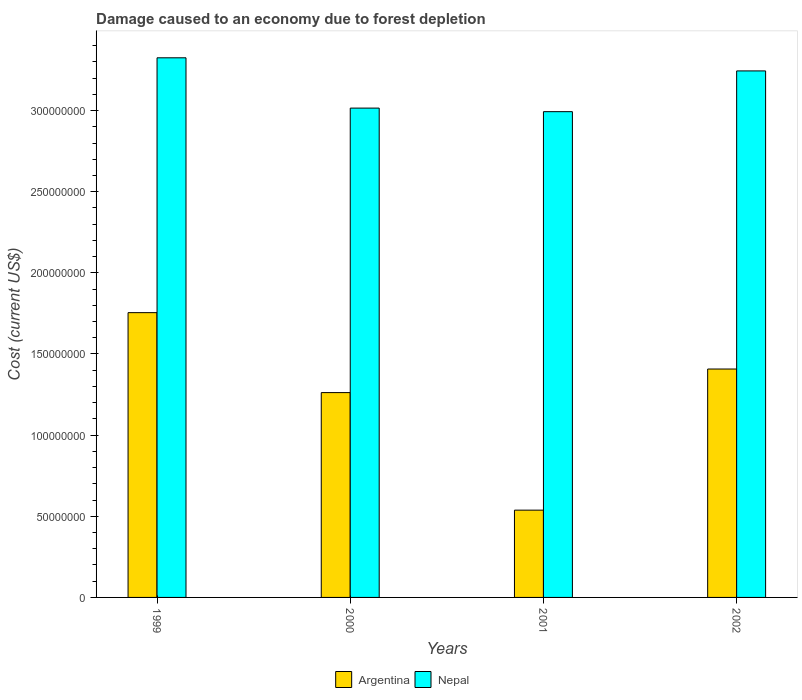Are the number of bars per tick equal to the number of legend labels?
Your answer should be very brief. Yes. How many bars are there on the 2nd tick from the left?
Offer a terse response. 2. How many bars are there on the 1st tick from the right?
Make the answer very short. 2. In how many cases, is the number of bars for a given year not equal to the number of legend labels?
Offer a terse response. 0. What is the cost of damage caused due to forest depletion in Nepal in 1999?
Your answer should be very brief. 3.33e+08. Across all years, what is the maximum cost of damage caused due to forest depletion in Nepal?
Give a very brief answer. 3.33e+08. Across all years, what is the minimum cost of damage caused due to forest depletion in Argentina?
Provide a short and direct response. 5.38e+07. In which year was the cost of damage caused due to forest depletion in Argentina maximum?
Provide a succinct answer. 1999. What is the total cost of damage caused due to forest depletion in Argentina in the graph?
Your answer should be very brief. 4.96e+08. What is the difference between the cost of damage caused due to forest depletion in Argentina in 2001 and that in 2002?
Provide a succinct answer. -8.70e+07. What is the difference between the cost of damage caused due to forest depletion in Nepal in 2000 and the cost of damage caused due to forest depletion in Argentina in 2001?
Your answer should be compact. 2.48e+08. What is the average cost of damage caused due to forest depletion in Argentina per year?
Offer a terse response. 1.24e+08. In the year 2001, what is the difference between the cost of damage caused due to forest depletion in Nepal and cost of damage caused due to forest depletion in Argentina?
Provide a short and direct response. 2.46e+08. In how many years, is the cost of damage caused due to forest depletion in Argentina greater than 320000000 US$?
Give a very brief answer. 0. What is the ratio of the cost of damage caused due to forest depletion in Argentina in 1999 to that in 2002?
Offer a very short reply. 1.25. Is the cost of damage caused due to forest depletion in Argentina in 1999 less than that in 2000?
Ensure brevity in your answer.  No. Is the difference between the cost of damage caused due to forest depletion in Nepal in 2000 and 2001 greater than the difference between the cost of damage caused due to forest depletion in Argentina in 2000 and 2001?
Ensure brevity in your answer.  No. What is the difference between the highest and the second highest cost of damage caused due to forest depletion in Argentina?
Offer a terse response. 3.47e+07. What is the difference between the highest and the lowest cost of damage caused due to forest depletion in Nepal?
Your answer should be compact. 3.32e+07. In how many years, is the cost of damage caused due to forest depletion in Nepal greater than the average cost of damage caused due to forest depletion in Nepal taken over all years?
Make the answer very short. 2. Is the sum of the cost of damage caused due to forest depletion in Argentina in 1999 and 2001 greater than the maximum cost of damage caused due to forest depletion in Nepal across all years?
Provide a short and direct response. No. What does the 2nd bar from the left in 1999 represents?
Ensure brevity in your answer.  Nepal. What does the 1st bar from the right in 2000 represents?
Keep it short and to the point. Nepal. How many bars are there?
Offer a terse response. 8. Are all the bars in the graph horizontal?
Offer a terse response. No. Does the graph contain any zero values?
Give a very brief answer. No. Where does the legend appear in the graph?
Give a very brief answer. Bottom center. How many legend labels are there?
Provide a short and direct response. 2. How are the legend labels stacked?
Provide a short and direct response. Horizontal. What is the title of the graph?
Provide a short and direct response. Damage caused to an economy due to forest depletion. What is the label or title of the X-axis?
Provide a short and direct response. Years. What is the label or title of the Y-axis?
Ensure brevity in your answer.  Cost (current US$). What is the Cost (current US$) in Argentina in 1999?
Give a very brief answer. 1.75e+08. What is the Cost (current US$) of Nepal in 1999?
Keep it short and to the point. 3.33e+08. What is the Cost (current US$) of Argentina in 2000?
Provide a short and direct response. 1.26e+08. What is the Cost (current US$) in Nepal in 2000?
Your answer should be very brief. 3.02e+08. What is the Cost (current US$) of Argentina in 2001?
Provide a short and direct response. 5.38e+07. What is the Cost (current US$) in Nepal in 2001?
Keep it short and to the point. 2.99e+08. What is the Cost (current US$) of Argentina in 2002?
Make the answer very short. 1.41e+08. What is the Cost (current US$) in Nepal in 2002?
Your response must be concise. 3.24e+08. Across all years, what is the maximum Cost (current US$) of Argentina?
Keep it short and to the point. 1.75e+08. Across all years, what is the maximum Cost (current US$) of Nepal?
Offer a very short reply. 3.33e+08. Across all years, what is the minimum Cost (current US$) in Argentina?
Provide a short and direct response. 5.38e+07. Across all years, what is the minimum Cost (current US$) in Nepal?
Your answer should be compact. 2.99e+08. What is the total Cost (current US$) of Argentina in the graph?
Offer a very short reply. 4.96e+08. What is the total Cost (current US$) of Nepal in the graph?
Make the answer very short. 1.26e+09. What is the difference between the Cost (current US$) in Argentina in 1999 and that in 2000?
Offer a very short reply. 4.93e+07. What is the difference between the Cost (current US$) in Nepal in 1999 and that in 2000?
Make the answer very short. 3.10e+07. What is the difference between the Cost (current US$) of Argentina in 1999 and that in 2001?
Offer a terse response. 1.22e+08. What is the difference between the Cost (current US$) of Nepal in 1999 and that in 2001?
Give a very brief answer. 3.32e+07. What is the difference between the Cost (current US$) in Argentina in 1999 and that in 2002?
Offer a very short reply. 3.47e+07. What is the difference between the Cost (current US$) in Nepal in 1999 and that in 2002?
Offer a very short reply. 8.07e+06. What is the difference between the Cost (current US$) of Argentina in 2000 and that in 2001?
Provide a short and direct response. 7.24e+07. What is the difference between the Cost (current US$) of Nepal in 2000 and that in 2001?
Provide a succinct answer. 2.19e+06. What is the difference between the Cost (current US$) in Argentina in 2000 and that in 2002?
Offer a terse response. -1.45e+07. What is the difference between the Cost (current US$) in Nepal in 2000 and that in 2002?
Give a very brief answer. -2.29e+07. What is the difference between the Cost (current US$) in Argentina in 2001 and that in 2002?
Your response must be concise. -8.70e+07. What is the difference between the Cost (current US$) in Nepal in 2001 and that in 2002?
Ensure brevity in your answer.  -2.51e+07. What is the difference between the Cost (current US$) of Argentina in 1999 and the Cost (current US$) of Nepal in 2000?
Offer a very short reply. -1.26e+08. What is the difference between the Cost (current US$) of Argentina in 1999 and the Cost (current US$) of Nepal in 2001?
Offer a very short reply. -1.24e+08. What is the difference between the Cost (current US$) of Argentina in 1999 and the Cost (current US$) of Nepal in 2002?
Keep it short and to the point. -1.49e+08. What is the difference between the Cost (current US$) of Argentina in 2000 and the Cost (current US$) of Nepal in 2001?
Offer a very short reply. -1.73e+08. What is the difference between the Cost (current US$) of Argentina in 2000 and the Cost (current US$) of Nepal in 2002?
Keep it short and to the point. -1.98e+08. What is the difference between the Cost (current US$) of Argentina in 2001 and the Cost (current US$) of Nepal in 2002?
Offer a terse response. -2.71e+08. What is the average Cost (current US$) in Argentina per year?
Your answer should be very brief. 1.24e+08. What is the average Cost (current US$) of Nepal per year?
Ensure brevity in your answer.  3.14e+08. In the year 1999, what is the difference between the Cost (current US$) in Argentina and Cost (current US$) in Nepal?
Your answer should be very brief. -1.57e+08. In the year 2000, what is the difference between the Cost (current US$) in Argentina and Cost (current US$) in Nepal?
Keep it short and to the point. -1.75e+08. In the year 2001, what is the difference between the Cost (current US$) of Argentina and Cost (current US$) of Nepal?
Your answer should be very brief. -2.46e+08. In the year 2002, what is the difference between the Cost (current US$) in Argentina and Cost (current US$) in Nepal?
Your response must be concise. -1.84e+08. What is the ratio of the Cost (current US$) of Argentina in 1999 to that in 2000?
Your answer should be very brief. 1.39. What is the ratio of the Cost (current US$) in Nepal in 1999 to that in 2000?
Offer a very short reply. 1.1. What is the ratio of the Cost (current US$) in Argentina in 1999 to that in 2001?
Your answer should be compact. 3.26. What is the ratio of the Cost (current US$) of Nepal in 1999 to that in 2001?
Offer a terse response. 1.11. What is the ratio of the Cost (current US$) of Argentina in 1999 to that in 2002?
Your answer should be compact. 1.25. What is the ratio of the Cost (current US$) in Nepal in 1999 to that in 2002?
Ensure brevity in your answer.  1.02. What is the ratio of the Cost (current US$) in Argentina in 2000 to that in 2001?
Keep it short and to the point. 2.35. What is the ratio of the Cost (current US$) of Nepal in 2000 to that in 2001?
Your response must be concise. 1.01. What is the ratio of the Cost (current US$) of Argentina in 2000 to that in 2002?
Ensure brevity in your answer.  0.9. What is the ratio of the Cost (current US$) in Nepal in 2000 to that in 2002?
Make the answer very short. 0.93. What is the ratio of the Cost (current US$) in Argentina in 2001 to that in 2002?
Offer a terse response. 0.38. What is the ratio of the Cost (current US$) of Nepal in 2001 to that in 2002?
Offer a terse response. 0.92. What is the difference between the highest and the second highest Cost (current US$) of Argentina?
Make the answer very short. 3.47e+07. What is the difference between the highest and the second highest Cost (current US$) of Nepal?
Provide a short and direct response. 8.07e+06. What is the difference between the highest and the lowest Cost (current US$) in Argentina?
Make the answer very short. 1.22e+08. What is the difference between the highest and the lowest Cost (current US$) of Nepal?
Your answer should be compact. 3.32e+07. 